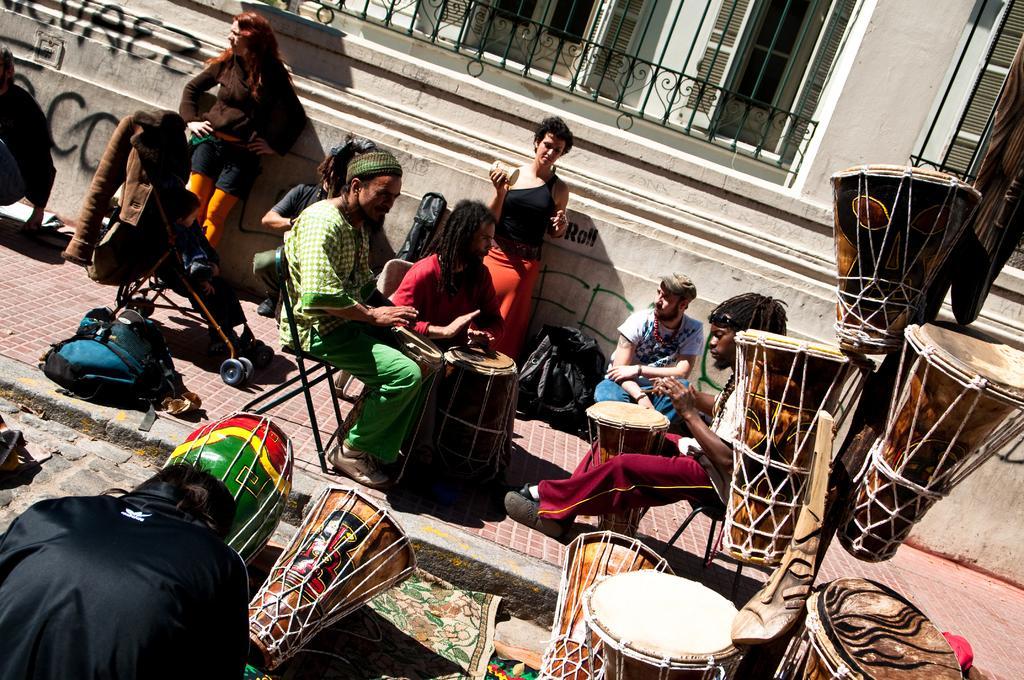How would you summarize this image in a sentence or two? There are three persons sitting in chairs and playing tabla and there are few persons beside them and there are some tablas in the right corner. 